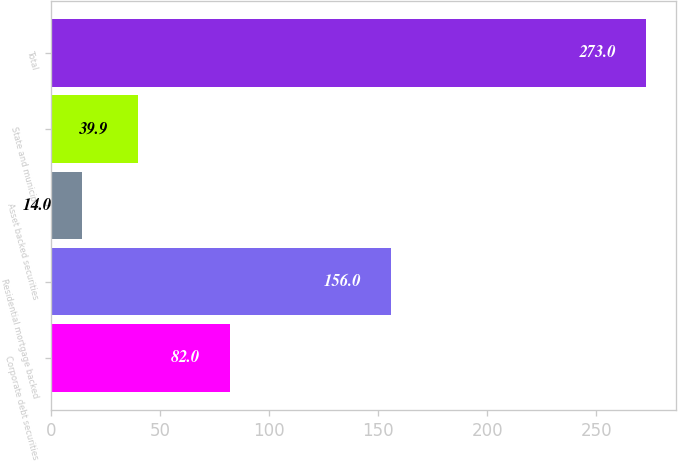Convert chart to OTSL. <chart><loc_0><loc_0><loc_500><loc_500><bar_chart><fcel>Corporate debt securities<fcel>Residential mortgage backed<fcel>Asset backed securities<fcel>State and municipal<fcel>Total<nl><fcel>82<fcel>156<fcel>14<fcel>39.9<fcel>273<nl></chart> 